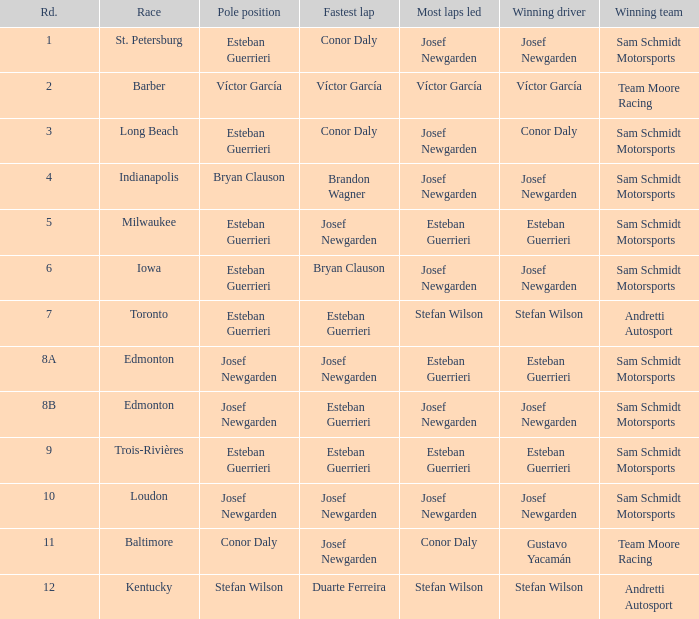During which event did josef newgarden record the quickest lap and dominate the most laps? Loudon. 